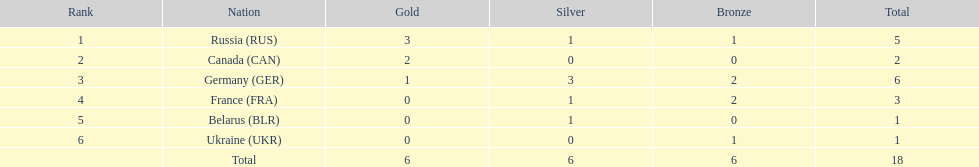Between france and canada, who secured more total medals? France. 